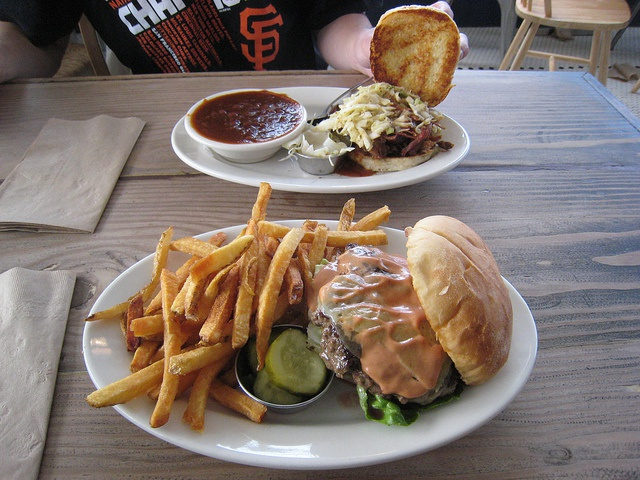Describe the objects in this image and their specific colors. I can see dining table in darkgray, gray, black, and brown tones, sandwich in black, gray, brown, maroon, and tan tones, people in black, maroon, darkgray, and gray tones, sandwich in black, olive, tan, maroon, and gray tones, and bowl in black, maroon, darkgray, and lightgray tones in this image. 